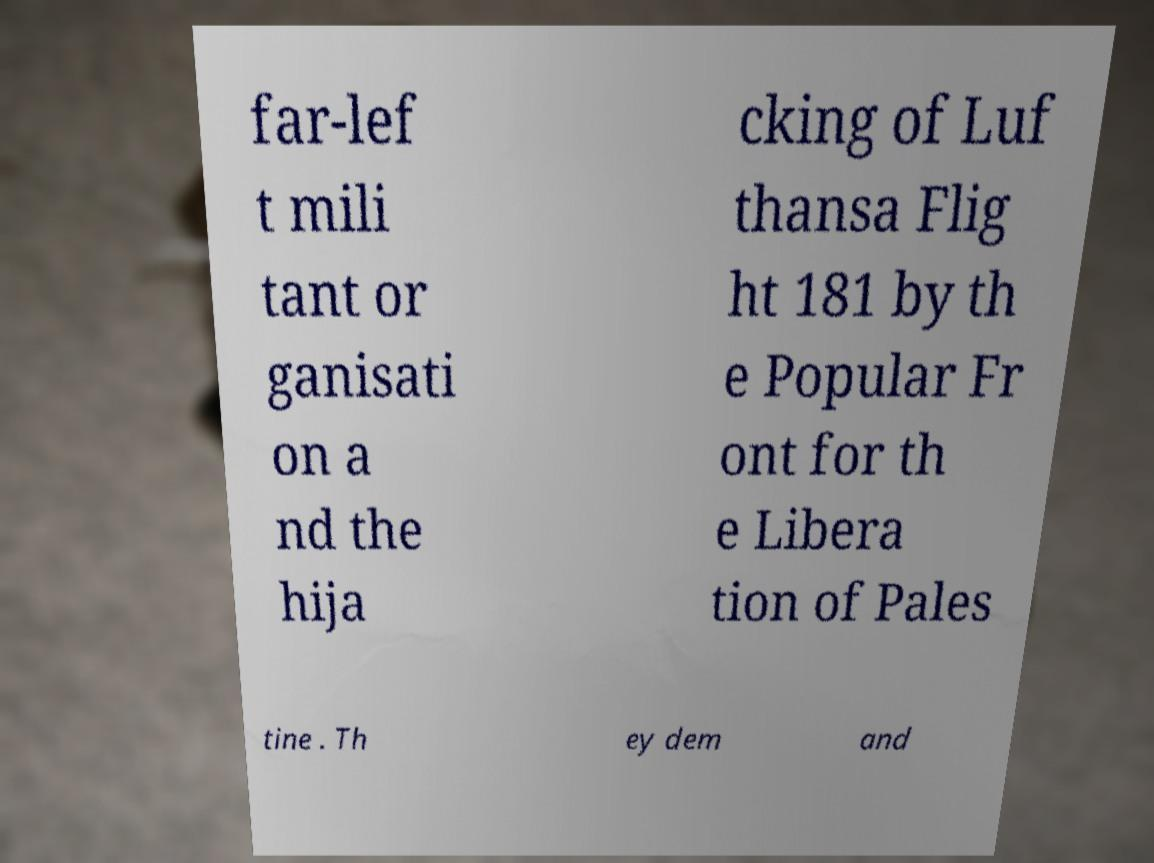Can you accurately transcribe the text from the provided image for me? far-lef t mili tant or ganisati on a nd the hija cking of Luf thansa Flig ht 181 by th e Popular Fr ont for th e Libera tion of Pales tine . Th ey dem and 